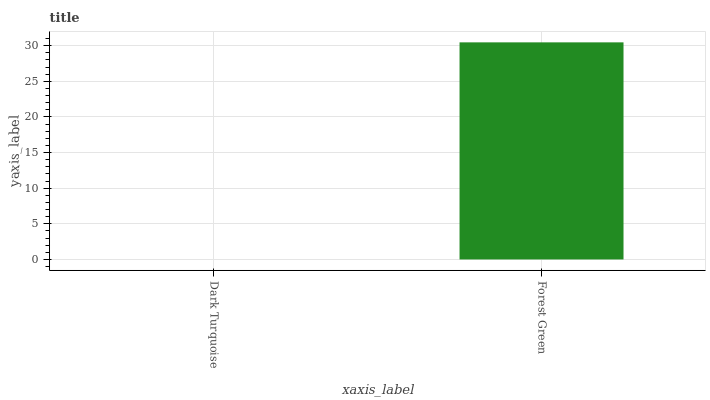Is Dark Turquoise the minimum?
Answer yes or no. Yes. Is Forest Green the maximum?
Answer yes or no. Yes. Is Forest Green the minimum?
Answer yes or no. No. Is Forest Green greater than Dark Turquoise?
Answer yes or no. Yes. Is Dark Turquoise less than Forest Green?
Answer yes or no. Yes. Is Dark Turquoise greater than Forest Green?
Answer yes or no. No. Is Forest Green less than Dark Turquoise?
Answer yes or no. No. Is Forest Green the high median?
Answer yes or no. Yes. Is Dark Turquoise the low median?
Answer yes or no. Yes. Is Dark Turquoise the high median?
Answer yes or no. No. Is Forest Green the low median?
Answer yes or no. No. 